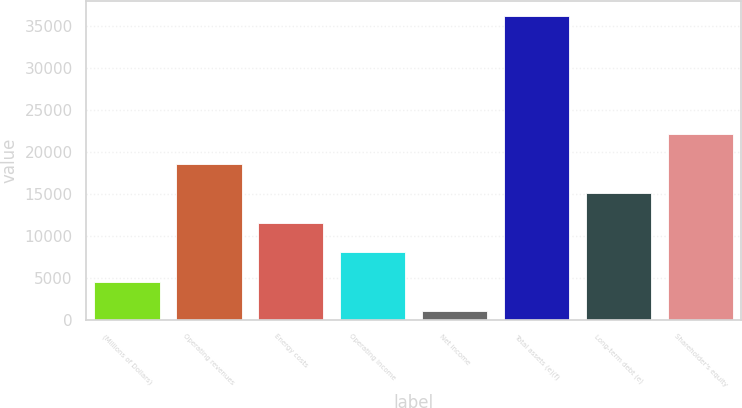Convert chart to OTSL. <chart><loc_0><loc_0><loc_500><loc_500><bar_chart><fcel>(Millions of Dollars)<fcel>Operating revenues<fcel>Energy costs<fcel>Operating income<fcel>Net income<fcel>Total assets (e)(f)<fcel>Long-term debt (e)<fcel>Shareholder's equity<nl><fcel>4527.5<fcel>18557.5<fcel>11542.5<fcel>8035<fcel>1020<fcel>36095<fcel>15050<fcel>22065<nl></chart> 